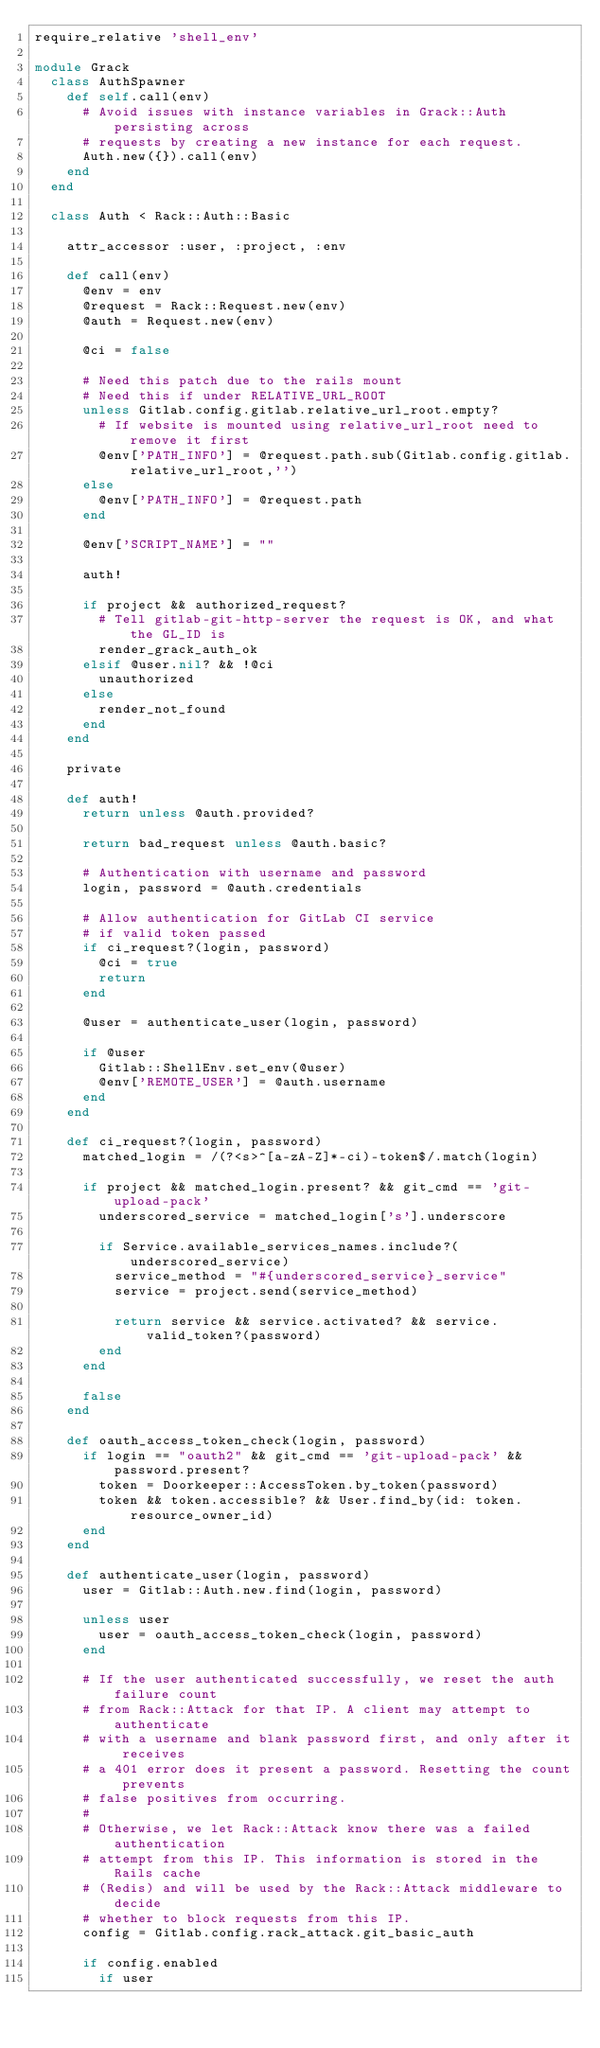<code> <loc_0><loc_0><loc_500><loc_500><_Ruby_>require_relative 'shell_env'

module Grack
  class AuthSpawner
    def self.call(env)
      # Avoid issues with instance variables in Grack::Auth persisting across
      # requests by creating a new instance for each request.
      Auth.new({}).call(env)
    end
  end

  class Auth < Rack::Auth::Basic

    attr_accessor :user, :project, :env

    def call(env)
      @env = env
      @request = Rack::Request.new(env)
      @auth = Request.new(env)

      @ci = false

      # Need this patch due to the rails mount
      # Need this if under RELATIVE_URL_ROOT
      unless Gitlab.config.gitlab.relative_url_root.empty?
        # If website is mounted using relative_url_root need to remove it first
        @env['PATH_INFO'] = @request.path.sub(Gitlab.config.gitlab.relative_url_root,'')
      else
        @env['PATH_INFO'] = @request.path
      end

      @env['SCRIPT_NAME'] = ""

      auth!

      if project && authorized_request?
        # Tell gitlab-git-http-server the request is OK, and what the GL_ID is
        render_grack_auth_ok
      elsif @user.nil? && !@ci
        unauthorized
      else
        render_not_found
      end
    end

    private

    def auth!
      return unless @auth.provided?

      return bad_request unless @auth.basic?

      # Authentication with username and password
      login, password = @auth.credentials

      # Allow authentication for GitLab CI service
      # if valid token passed
      if ci_request?(login, password)
        @ci = true
        return
      end

      @user = authenticate_user(login, password)

      if @user
        Gitlab::ShellEnv.set_env(@user)
        @env['REMOTE_USER'] = @auth.username
      end
    end

    def ci_request?(login, password)
      matched_login = /(?<s>^[a-zA-Z]*-ci)-token$/.match(login)

      if project && matched_login.present? && git_cmd == 'git-upload-pack'
        underscored_service = matched_login['s'].underscore 

        if Service.available_services_names.include?(underscored_service)
          service_method = "#{underscored_service}_service"
          service = project.send(service_method)

          return service && service.activated? && service.valid_token?(password)
        end
      end

      false
    end

    def oauth_access_token_check(login, password)
      if login == "oauth2" && git_cmd == 'git-upload-pack' && password.present?
        token = Doorkeeper::AccessToken.by_token(password)
        token && token.accessible? && User.find_by(id: token.resource_owner_id)
      end
    end

    def authenticate_user(login, password)
      user = Gitlab::Auth.new.find(login, password)

      unless user
        user = oauth_access_token_check(login, password)
      end

      # If the user authenticated successfully, we reset the auth failure count
      # from Rack::Attack for that IP. A client may attempt to authenticate
      # with a username and blank password first, and only after it receives
      # a 401 error does it present a password. Resetting the count prevents
      # false positives from occurring.
      #
      # Otherwise, we let Rack::Attack know there was a failed authentication
      # attempt from this IP. This information is stored in the Rails cache
      # (Redis) and will be used by the Rack::Attack middleware to decide
      # whether to block requests from this IP.
      config = Gitlab.config.rack_attack.git_basic_auth

      if config.enabled
        if user</code> 